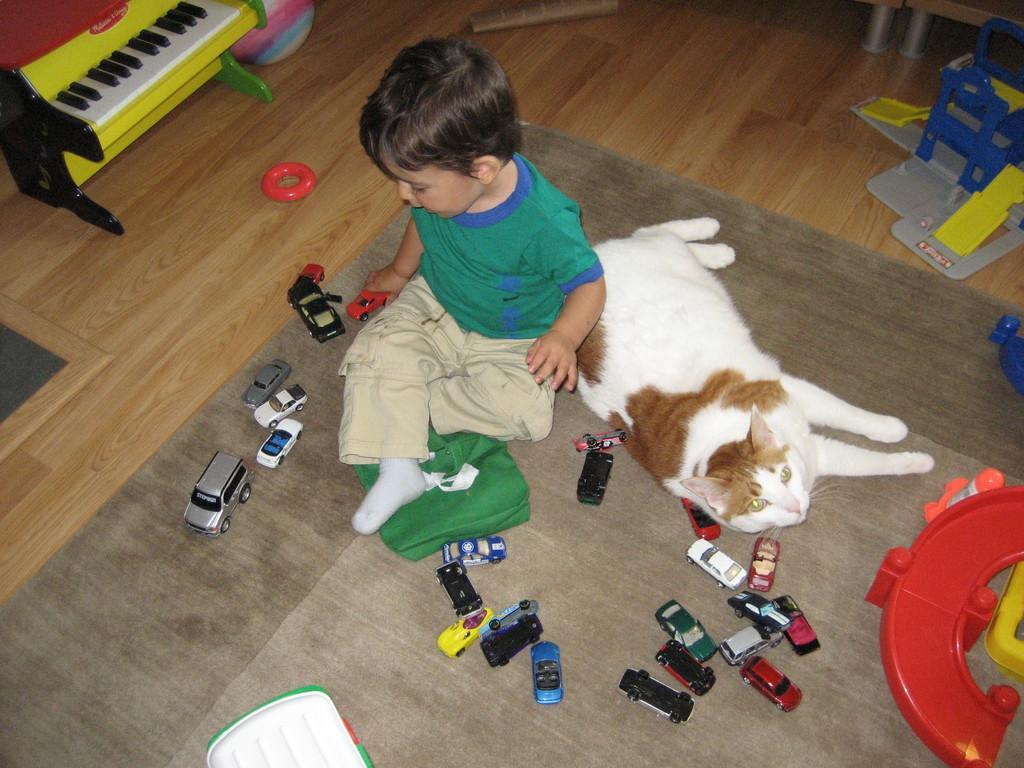Could you give a brief overview of what you see in this image? In this image we can see a boy playing with toys and there is a cat sleeping beside to this boy. 